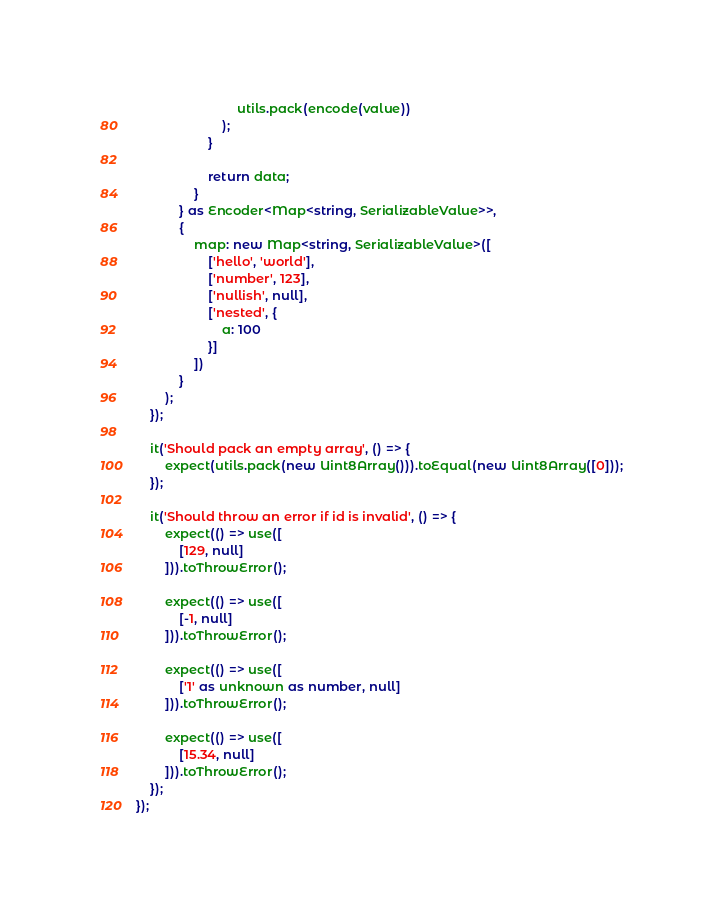<code> <loc_0><loc_0><loc_500><loc_500><_TypeScript_>                            utils.pack(encode(value))
                        );
                    }

                    return data;
                }
            } as Encoder<Map<string, SerializableValue>>,
            {
                map: new Map<string, SerializableValue>([
                    ['hello', 'world'],
                    ['number', 123],
                    ['nullish', null],
                    ['nested', {
                        a: 100
                    }]
                ])
            }
        );
    });

    it('Should pack an empty array', () => {
        expect(utils.pack(new Uint8Array())).toEqual(new Uint8Array([0]));
    });

    it('Should throw an error if id is invalid', () => {
        expect(() => use([
            [129, null]
        ])).toThrowError();

        expect(() => use([
            [-1, null]
        ])).toThrowError();

        expect(() => use([
            ['1' as unknown as number, null]
        ])).toThrowError();

        expect(() => use([
            [15.34, null]
        ])).toThrowError();
    });
});

</code> 